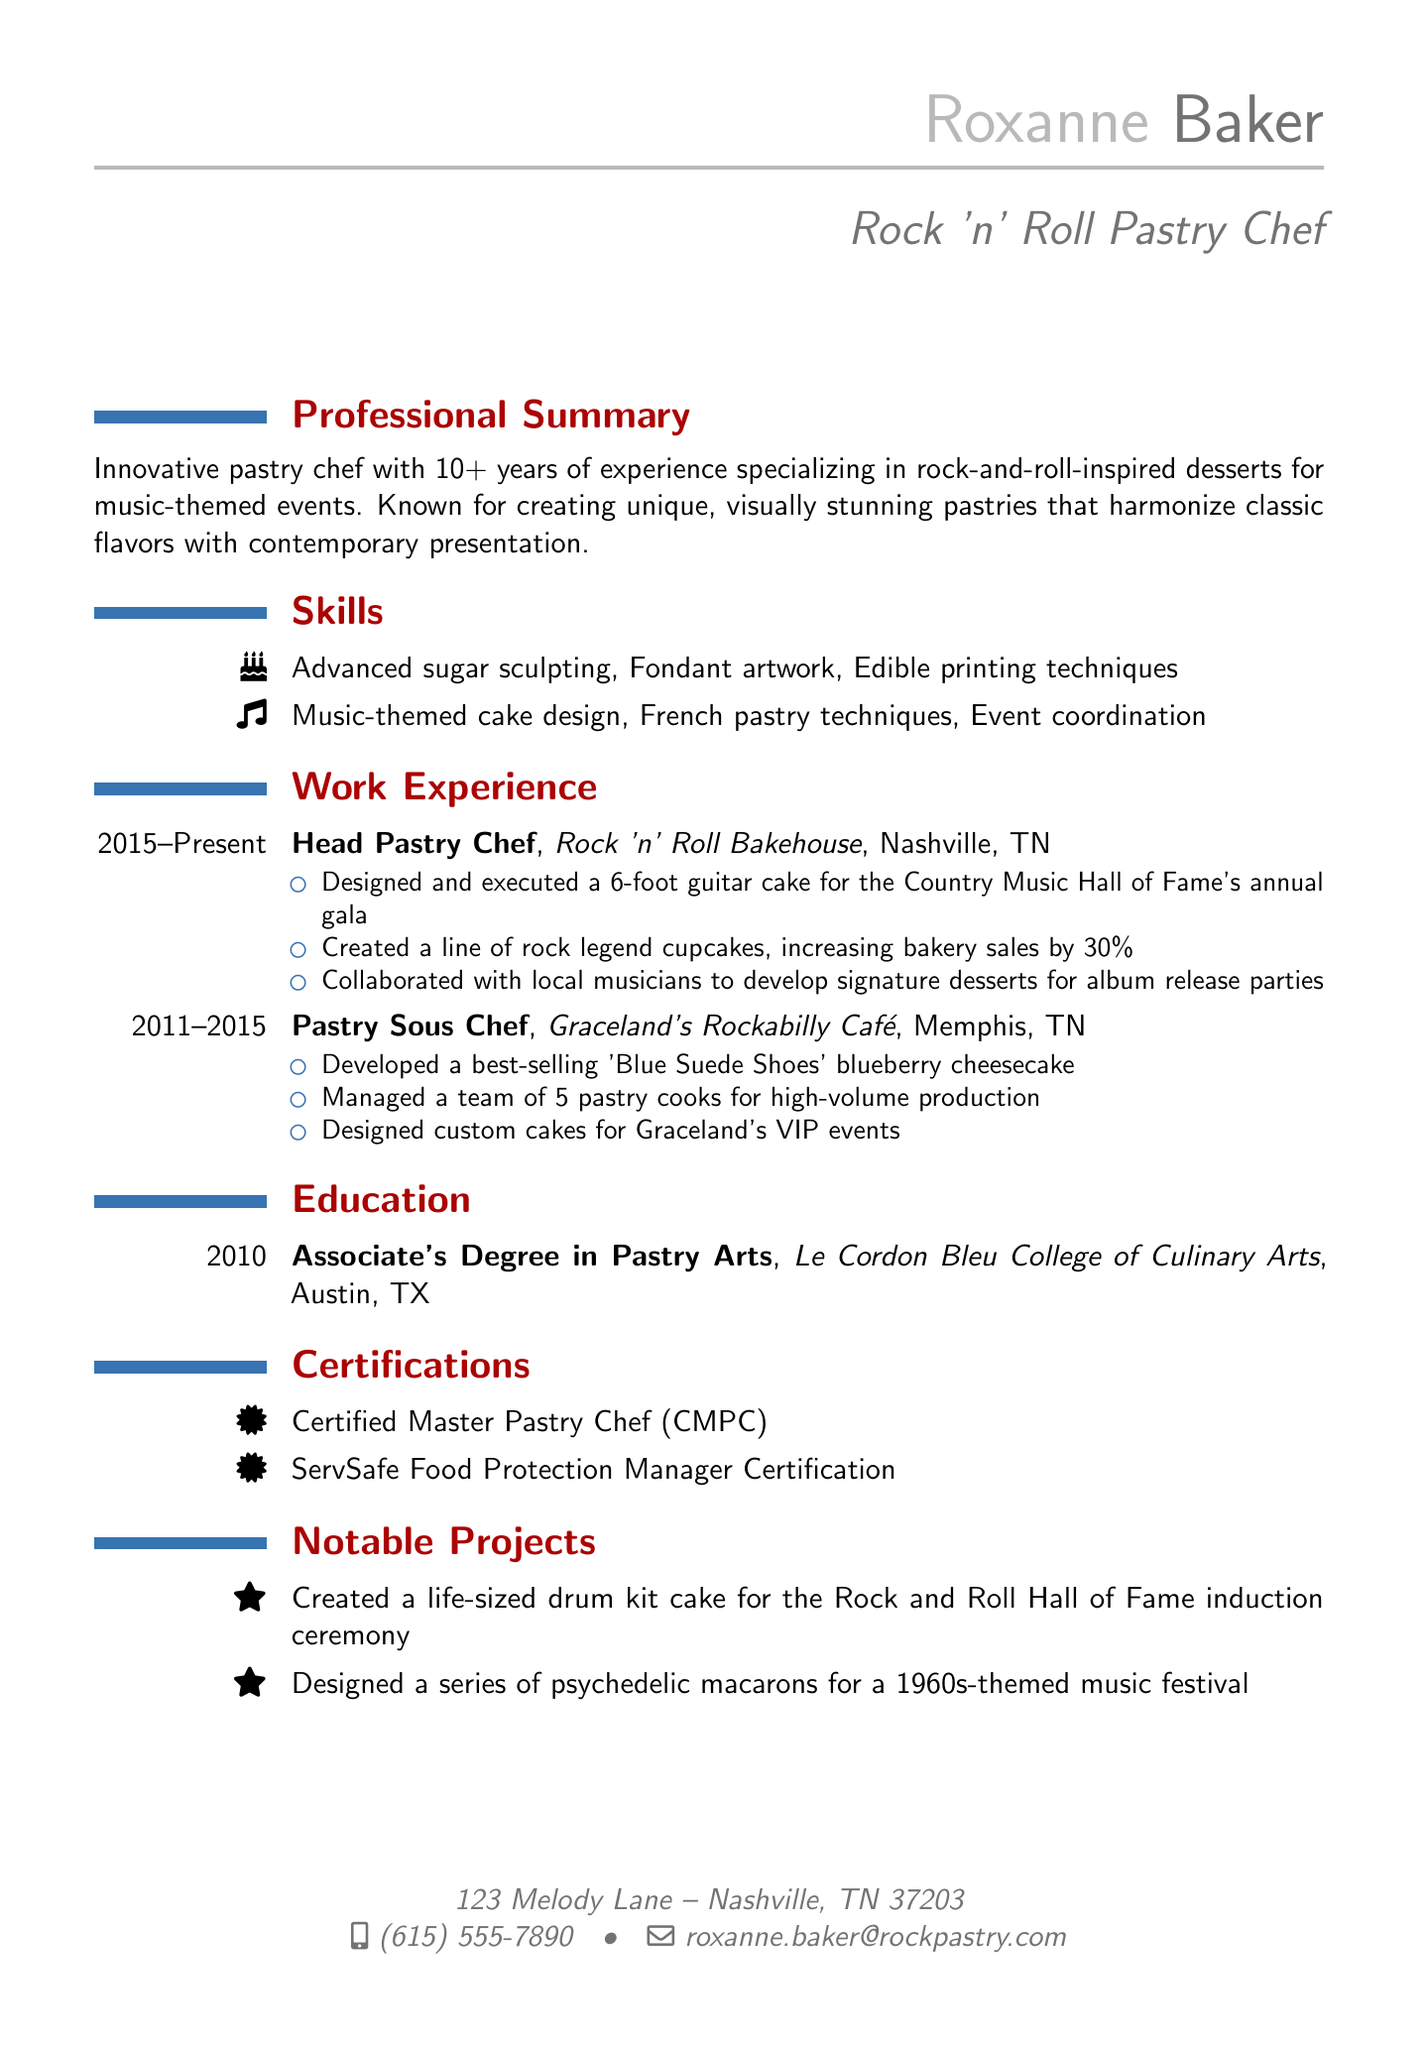What is Roxanne's email address? The email address listed in the personal information section is what the question is asking for.
Answer: roxanne.baker@rockpastry.com How many years of experience does Roxanne have? The professional summary states that Roxanne has 10+ years of experience in her field.
Answer: 10+ What position does Roxanne currently hold? The work experience section indicates her current job title, which is the subject of the question.
Answer: Head Pastry Chef What notable project involved a life-sized cake? The notable projects section lists a specific project that corresponds to the question about a life-sized cake.
Answer: drum kit cake Which café did Roxanne work for between 2011 and 2015? The work experience section specifies the name of the café where she held the position of pastry sous chef during that time.
Answer: Graceland's Rockabilly Café What type of degree does Roxanne have? The education section provides information about the type of degree she earned, relevant to the question.
Answer: Associate's Degree in Pastry Arts How much did bakery sales increase after introducing rock legend cupcakes? The achievements listed in her current role mention a specific percentage increase in sales due to her creations.
Answer: 30% What certification does Roxanne have related to food protection? The certifications section indicates the specific certification that pertains to food safety, aligning with the question's focus.
Answer: ServSafe Food Protection Manager Certification 